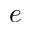<formula> <loc_0><loc_0><loc_500><loc_500>e</formula> 